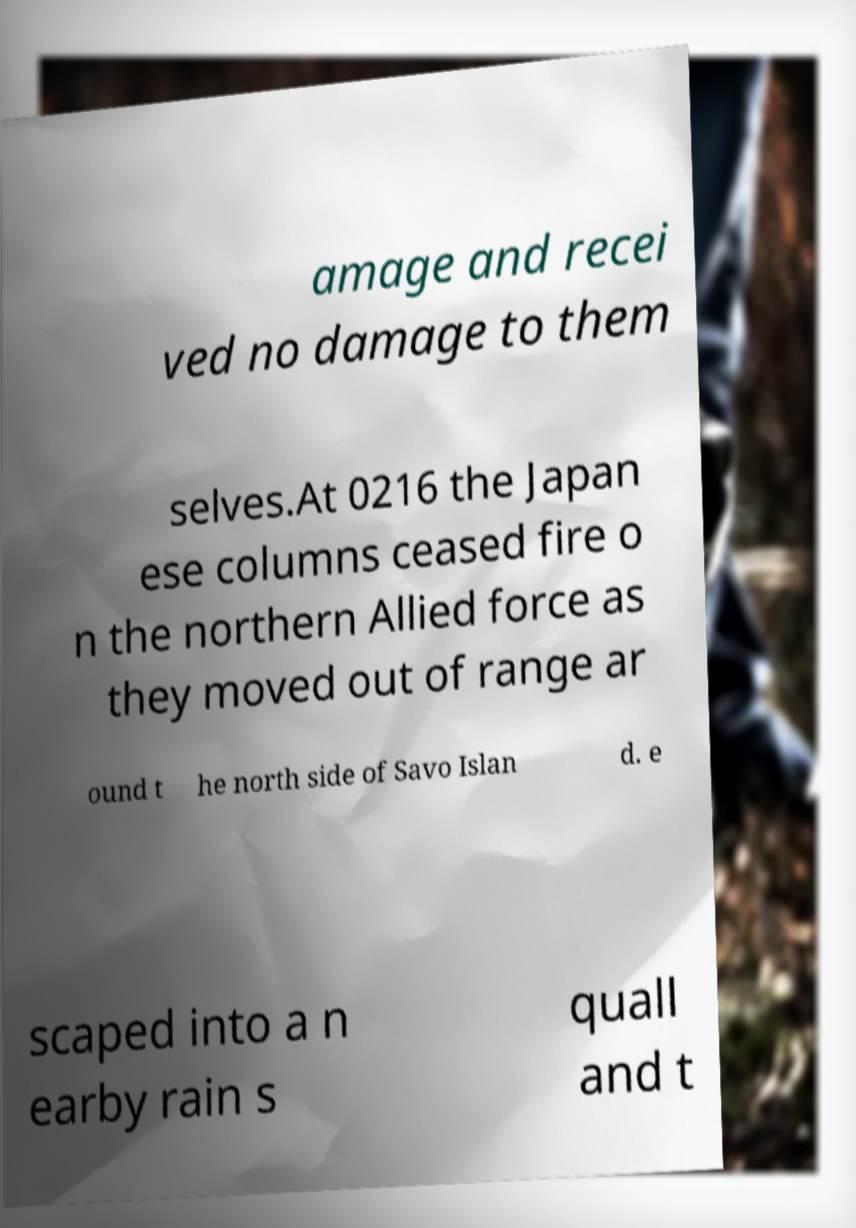There's text embedded in this image that I need extracted. Can you transcribe it verbatim? amage and recei ved no damage to them selves.At 0216 the Japan ese columns ceased fire o n the northern Allied force as they moved out of range ar ound t he north side of Savo Islan d. e scaped into a n earby rain s quall and t 